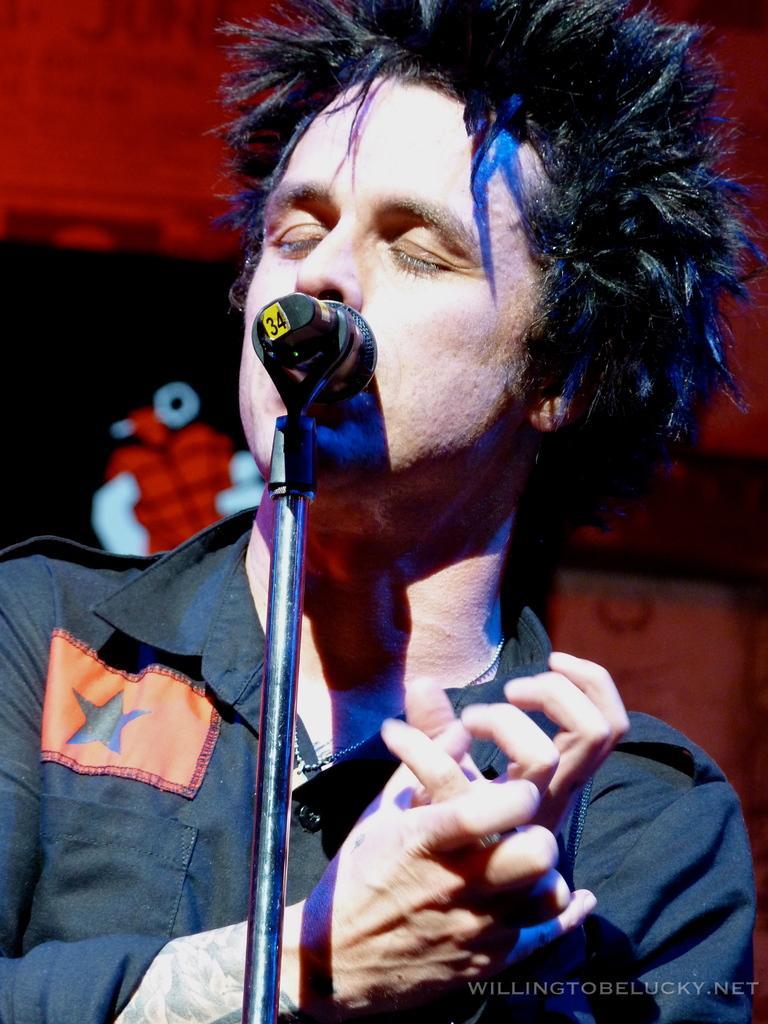Describe this image in one or two sentences. There is a man wearing a shirt. In front him there is a mic stand. In the right bottom corner there is a watermark 